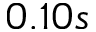Convert formula to latex. <formula><loc_0><loc_0><loc_500><loc_500>0 . 1 0 s</formula> 